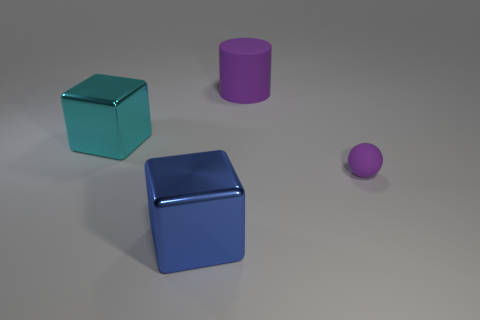There is a cube that is in front of the purple rubber object right of the large rubber object; what is its color?
Provide a succinct answer. Blue. Are there any big metal things of the same color as the cylinder?
Make the answer very short. No. There is another matte thing that is the same size as the blue object; what color is it?
Provide a succinct answer. Purple. Is the cube that is on the left side of the big blue metal object made of the same material as the purple cylinder?
Give a very brief answer. No. There is a cube in front of the matte thing on the right side of the big purple object; are there any small balls that are on the left side of it?
Your answer should be compact. No. Do the big shiny thing that is to the left of the blue metal thing and the tiny purple thing have the same shape?
Make the answer very short. No. The purple thing behind the purple matte thing in front of the large cylinder is what shape?
Give a very brief answer. Cylinder. What size is the purple matte thing in front of the purple rubber cylinder that is to the left of the purple rubber object that is to the right of the matte cylinder?
Provide a succinct answer. Small. There is another large thing that is the same shape as the large blue thing; what is its color?
Provide a short and direct response. Cyan. Do the matte cylinder and the matte ball have the same size?
Offer a terse response. No. 